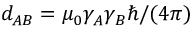Convert formula to latex. <formula><loc_0><loc_0><loc_500><loc_500>d _ { A B } = \mu _ { 0 } \gamma _ { A } \gamma _ { B } \hbar { / } ( 4 \pi )</formula> 